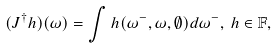<formula> <loc_0><loc_0><loc_500><loc_500>( J ^ { \dagger } h ) ( \omega ) = \int h ( \omega ^ { - } , \omega , \emptyset ) d \omega ^ { - } , \, h \in \mathbb { F } ,</formula> 